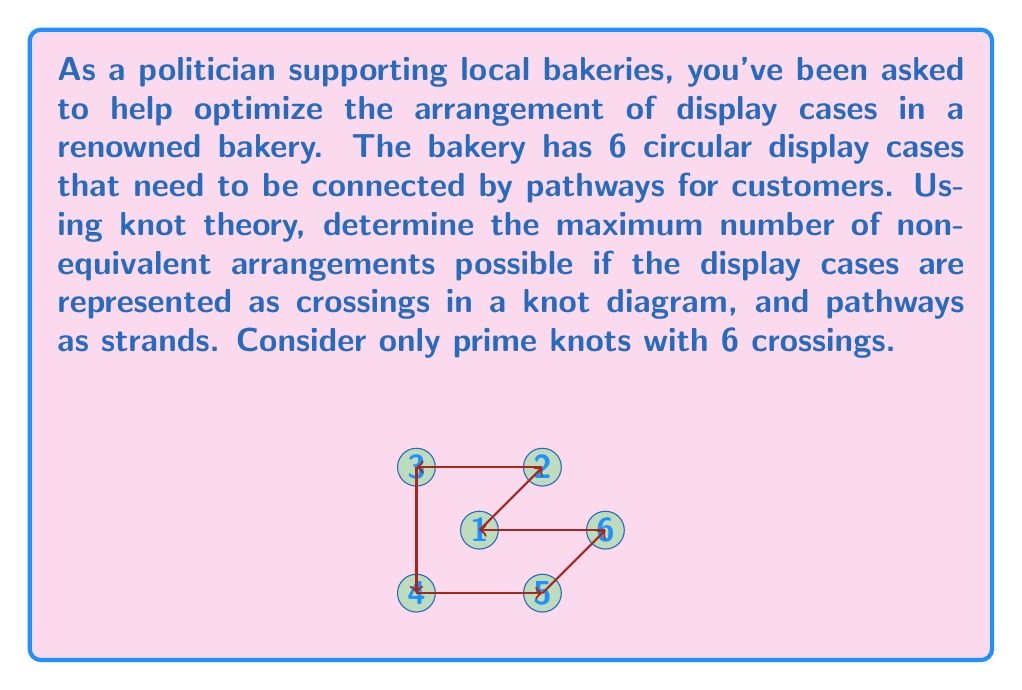Help me with this question. To solve this problem, we need to apply concepts from knot theory:

1. In knot theory, prime knots are knots that cannot be decomposed into simpler knots.

2. The number of crossings in a knot diagram corresponds to the number of display cases in our bakery layout.

3. For 6 crossings, we need to determine the number of distinct prime knots.

4. According to knot tables, there are exactly 3 prime knots with 6 crossings:
   - $6_1$ (Stevedore's knot)
   - $6_2$ (Figure-eight knot with a twist)
   - $6_3$ (Kinoshita-Terasaka knot)

5. Each of these knots represents a unique, non-equivalent arrangement of display cases and pathways in the bakery.

6. The knots $6_1$, $6_2$, and $6_3$ are topologically distinct, meaning they cannot be transformed into each other without cutting and rejoining the strand.

7. Therefore, these 3 prime knots represent the maximum number of non-equivalent arrangements possible for 6 display cases in the bakery.

This topological approach ensures that we have considered all possible unique layouts that optimize customer flow and maximize the visibility of bakery products.
Answer: 3 non-equivalent arrangements 